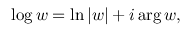<formula> <loc_0><loc_0><loc_500><loc_500>\log w = \ln | w | + i \arg w ,</formula> 